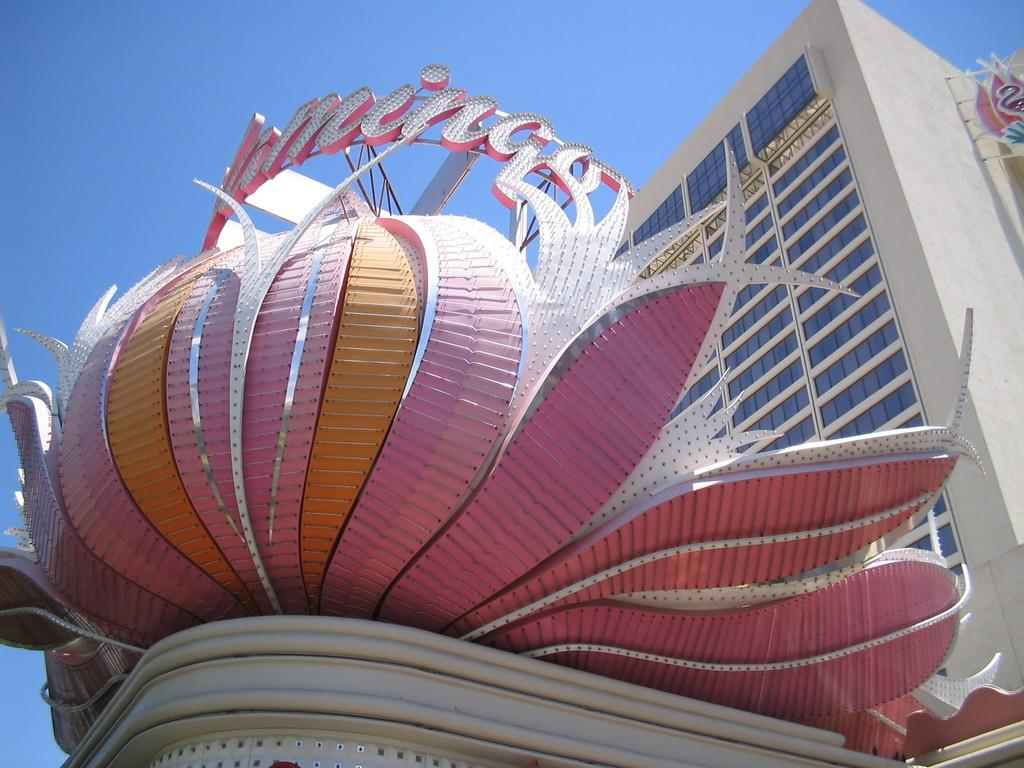What type of structure is present in the image? There is a building in the image. What can be seen in the background of the image? The sky is visible in the background of the image. What type of lettuce is being served by the governor in the image? There is no lettuce or governor present in the image; it only features a building and the sky. 